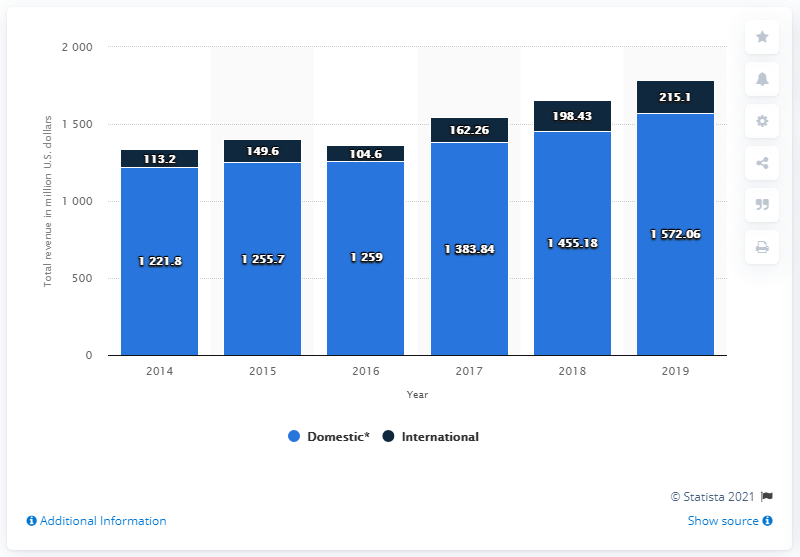Draw attention to some important aspects in this diagram. Which of the following has the highest value for all the years? Domestic product In 2019, the global domestic revenue of Steve Madden was $1572.06. In 2016, the difference between the two was 1154.4. 